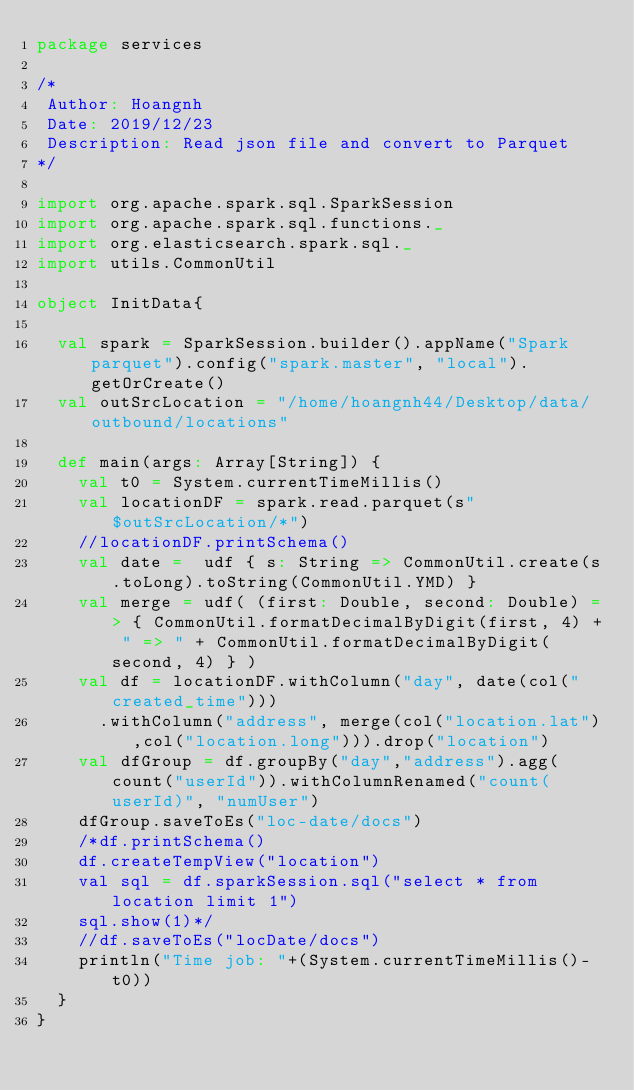Convert code to text. <code><loc_0><loc_0><loc_500><loc_500><_Scala_>package services

/*
 Author: Hoangnh
 Date: 2019/12/23
 Description: Read json file and convert to Parquet
*/

import org.apache.spark.sql.SparkSession
import org.apache.spark.sql.functions._
import org.elasticsearch.spark.sql._
import utils.CommonUtil

object InitData{

  val spark = SparkSession.builder().appName("Spark parquet").config("spark.master", "local").getOrCreate()
  val outSrcLocation = "/home/hoangnh44/Desktop/data/outbound/locations"

  def main(args: Array[String]) {
    val t0 = System.currentTimeMillis()
    val locationDF = spark.read.parquet(s"$outSrcLocation/*")
    //locationDF.printSchema()
    val date =  udf { s: String => CommonUtil.create(s.toLong).toString(CommonUtil.YMD) }
    val merge = udf( (first: Double, second: Double) => { CommonUtil.formatDecimalByDigit(first, 4) + " => " + CommonUtil.formatDecimalByDigit(second, 4) } )
    val df = locationDF.withColumn("day", date(col("created_time")))
      .withColumn("address", merge(col("location.lat"),col("location.long"))).drop("location")
    val dfGroup = df.groupBy("day","address").agg(count("userId")).withColumnRenamed("count(userId)", "numUser")
    dfGroup.saveToEs("loc-date/docs")
    /*df.printSchema()
    df.createTempView("location")
    val sql = df.sparkSession.sql("select * from location limit 1")
    sql.show(1)*/
    //df.saveToEs("locDate/docs")
    println("Time job: "+(System.currentTimeMillis()-t0))
  }
}
</code> 